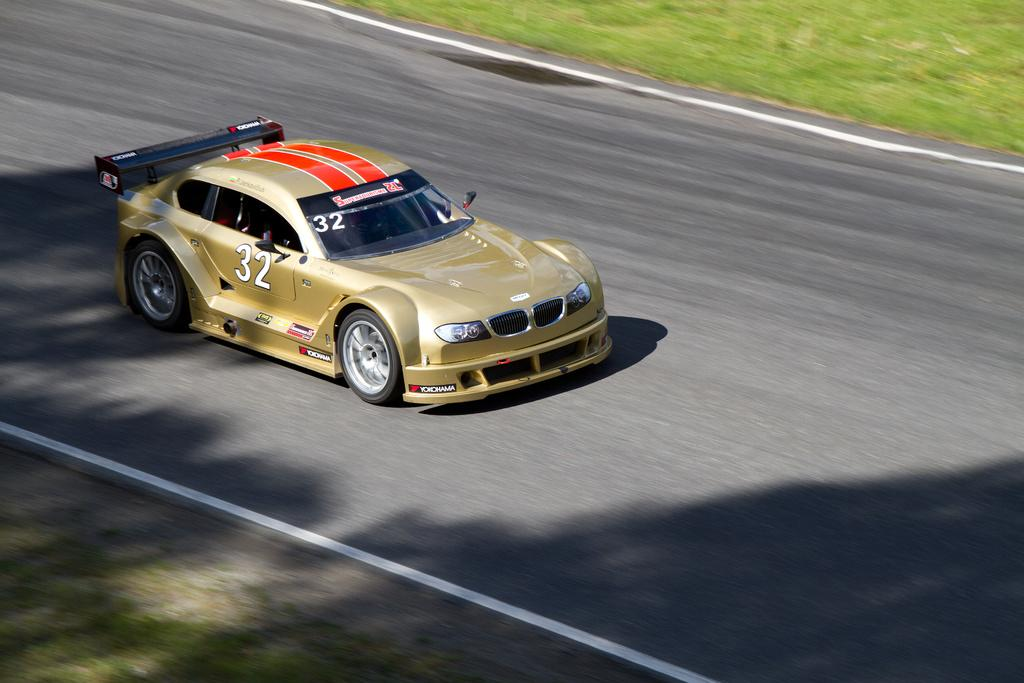What is the main subject of the image? The main subject of the image is a car. What is the car doing in the image? The car is moving on the road. What can be seen on both sides of the road in the image? There is grass on both sides of the road. What type of tin can be seen hanging from the car's rearview mirror in the image? There is no tin hanging from the car's rearview mirror in the image. What is the rate of the car's speed in the image? The image does not provide information about the car's speed, so we cannot determine its rate. 